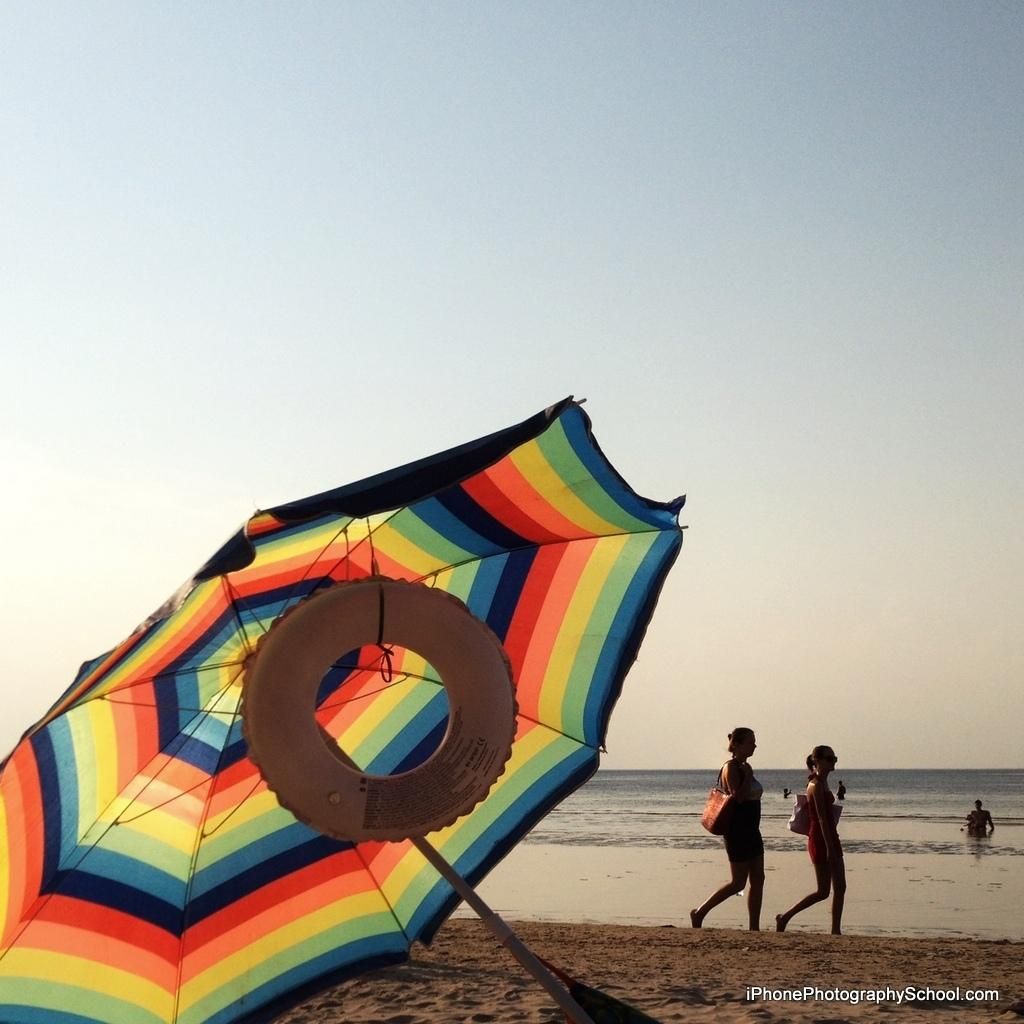What type of location is depicted in the image? There is a beach in the image. How many people are present on the beach? There are two people on the beach. What are the people doing or using in the image? The people are standing beside an umbrella. Can you describe any additional features of the umbrella? There is a tube tied to the umbrella. What type of hall can be seen in the background of the image? There is no hall present in the image; it depicts a beach with two people and an umbrella. 